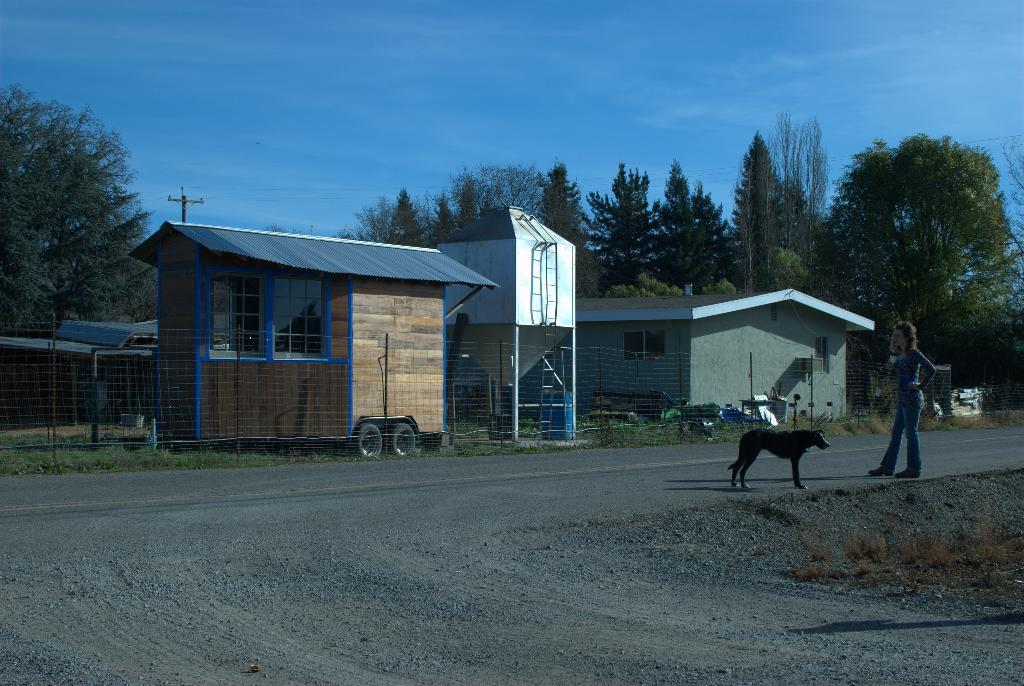What type of structures can be seen in the image? There are buildings in the image. What architectural features are present on the buildings? There are windows visible on the buildings. What is the large object in the image? There is a tank in the image. What type of fencing is present in the image? There is net fencing in the image. What are the tall, thin objects in the image? There are poles in the image. What type of vegetation is present in the image? There are trees in the image. Who or what is present in the image? There is a person and a dog in the image. What is the color of the sky in the image? The sky is blue in the image. Where are the chairs located in the image? There are no chairs present in the image. What type of powder can be seen on the person's face in the image? There is no powder visible on the person's face in the image. 